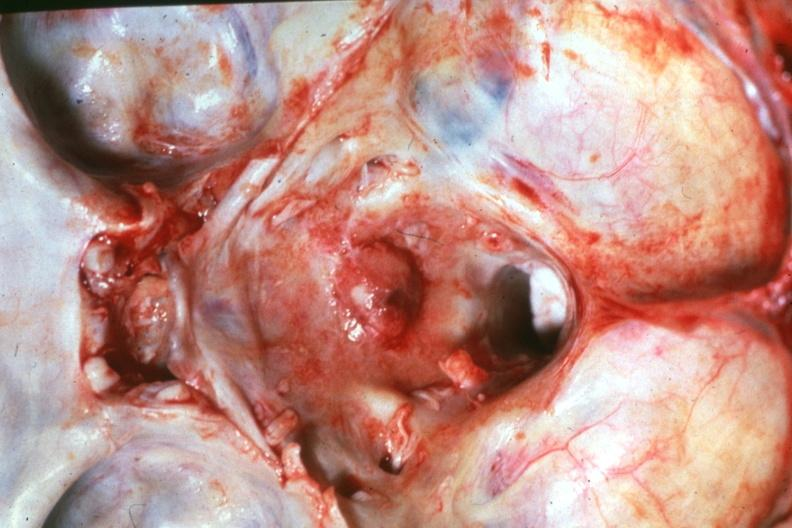does this image show close-up natural color dr garcia tumors b67?
Answer the question using a single word or phrase. Yes 